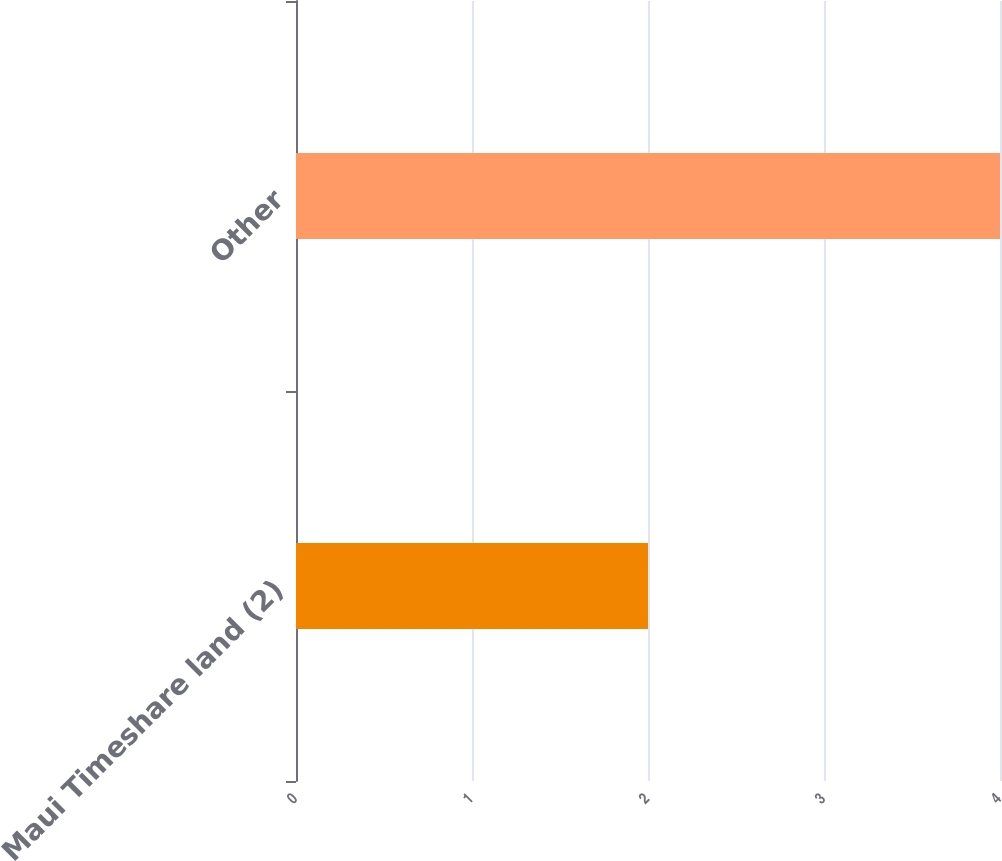<chart> <loc_0><loc_0><loc_500><loc_500><bar_chart><fcel>Maui Timeshare land (2)<fcel>Other<nl><fcel>2<fcel>4<nl></chart> 